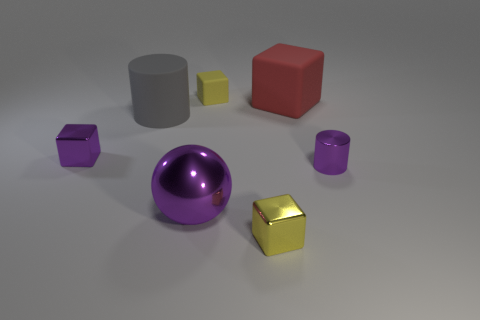Subtract all purple cylinders. How many cylinders are left? 1 Subtract all gray blocks. Subtract all red balls. How many blocks are left? 4 Subtract all green cylinders. How many yellow cubes are left? 2 Subtract all gray rubber things. Subtract all large gray objects. How many objects are left? 5 Add 4 purple metallic cubes. How many purple metallic cubes are left? 5 Add 7 large purple metal spheres. How many large purple metal spheres exist? 8 Add 1 cyan shiny blocks. How many objects exist? 8 Subtract all small rubber blocks. How many blocks are left? 3 Subtract 1 purple balls. How many objects are left? 6 Subtract all cubes. How many objects are left? 3 